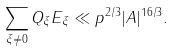Convert formula to latex. <formula><loc_0><loc_0><loc_500><loc_500>\sum _ { \xi \not = 0 } Q _ { \xi } E _ { \xi } \ll p ^ { 2 / 3 } | A | ^ { 1 6 / 3 } .</formula> 